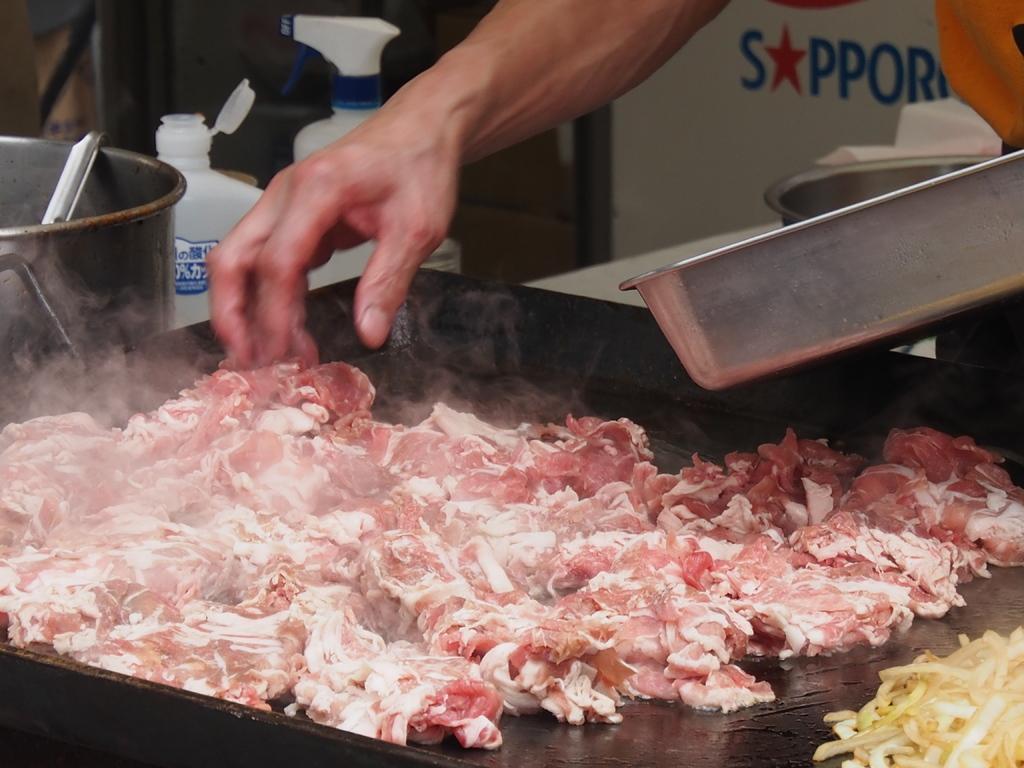How would you summarize this image in a sentence or two? In this image we can see meat placed on the cooking pan. In the background we can see person's hand, ladle, plastic containers and utensils. 